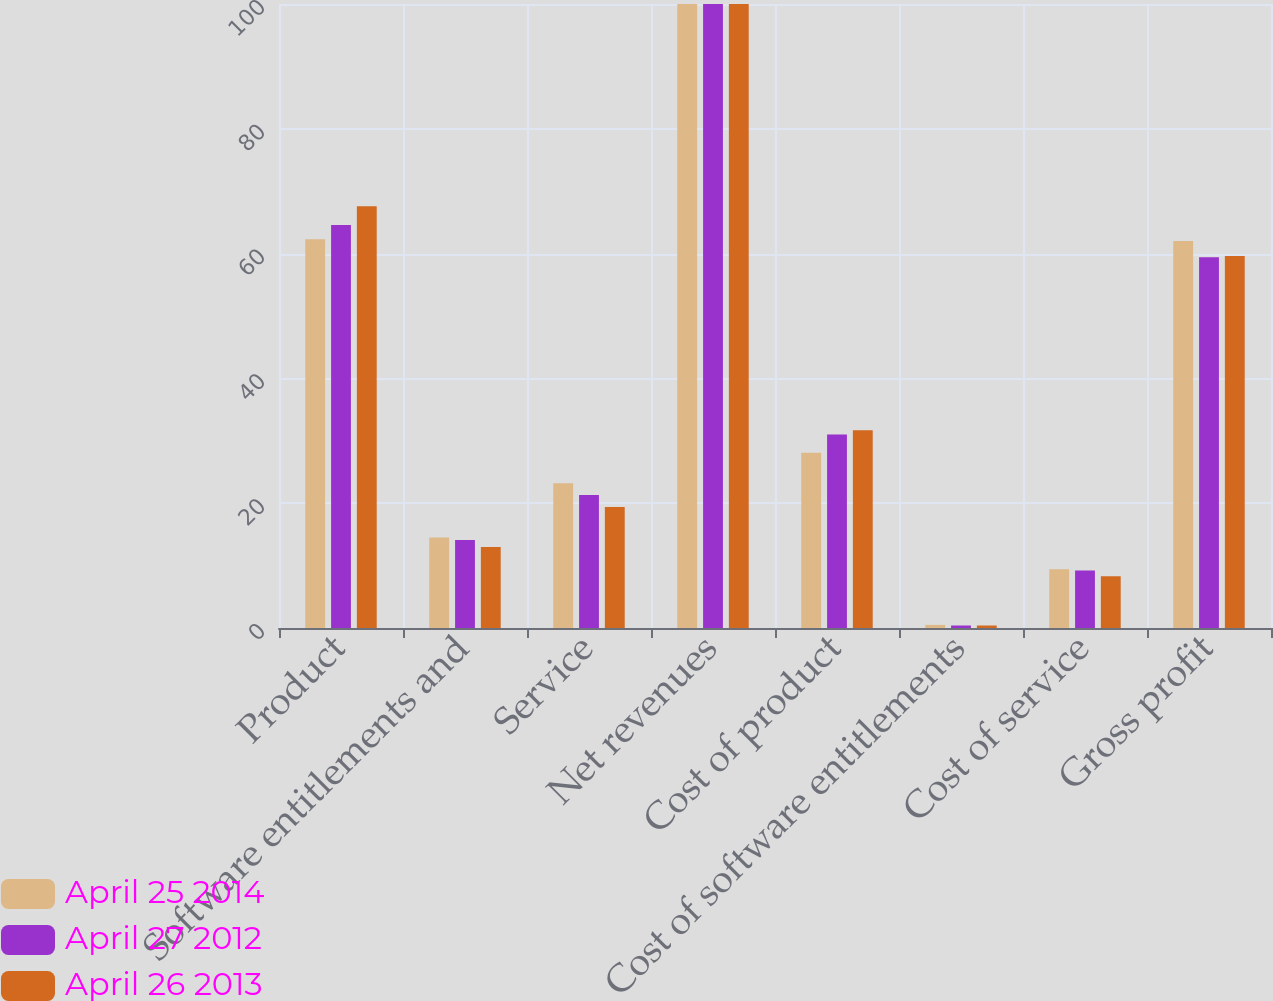<chart> <loc_0><loc_0><loc_500><loc_500><stacked_bar_chart><ecel><fcel>Product<fcel>Software entitlements and<fcel>Service<fcel>Net revenues<fcel>Cost of product<fcel>Cost of software entitlements<fcel>Cost of service<fcel>Gross profit<nl><fcel>April 25 2014<fcel>62.3<fcel>14.5<fcel>23.2<fcel>100<fcel>28.1<fcel>0.5<fcel>9.4<fcel>62<nl><fcel>April 27 2012<fcel>64.6<fcel>14.1<fcel>21.3<fcel>100<fcel>31<fcel>0.4<fcel>9.2<fcel>59.4<nl><fcel>April 26 2013<fcel>67.6<fcel>13<fcel>19.4<fcel>100<fcel>31.7<fcel>0.4<fcel>8.3<fcel>59.6<nl></chart> 